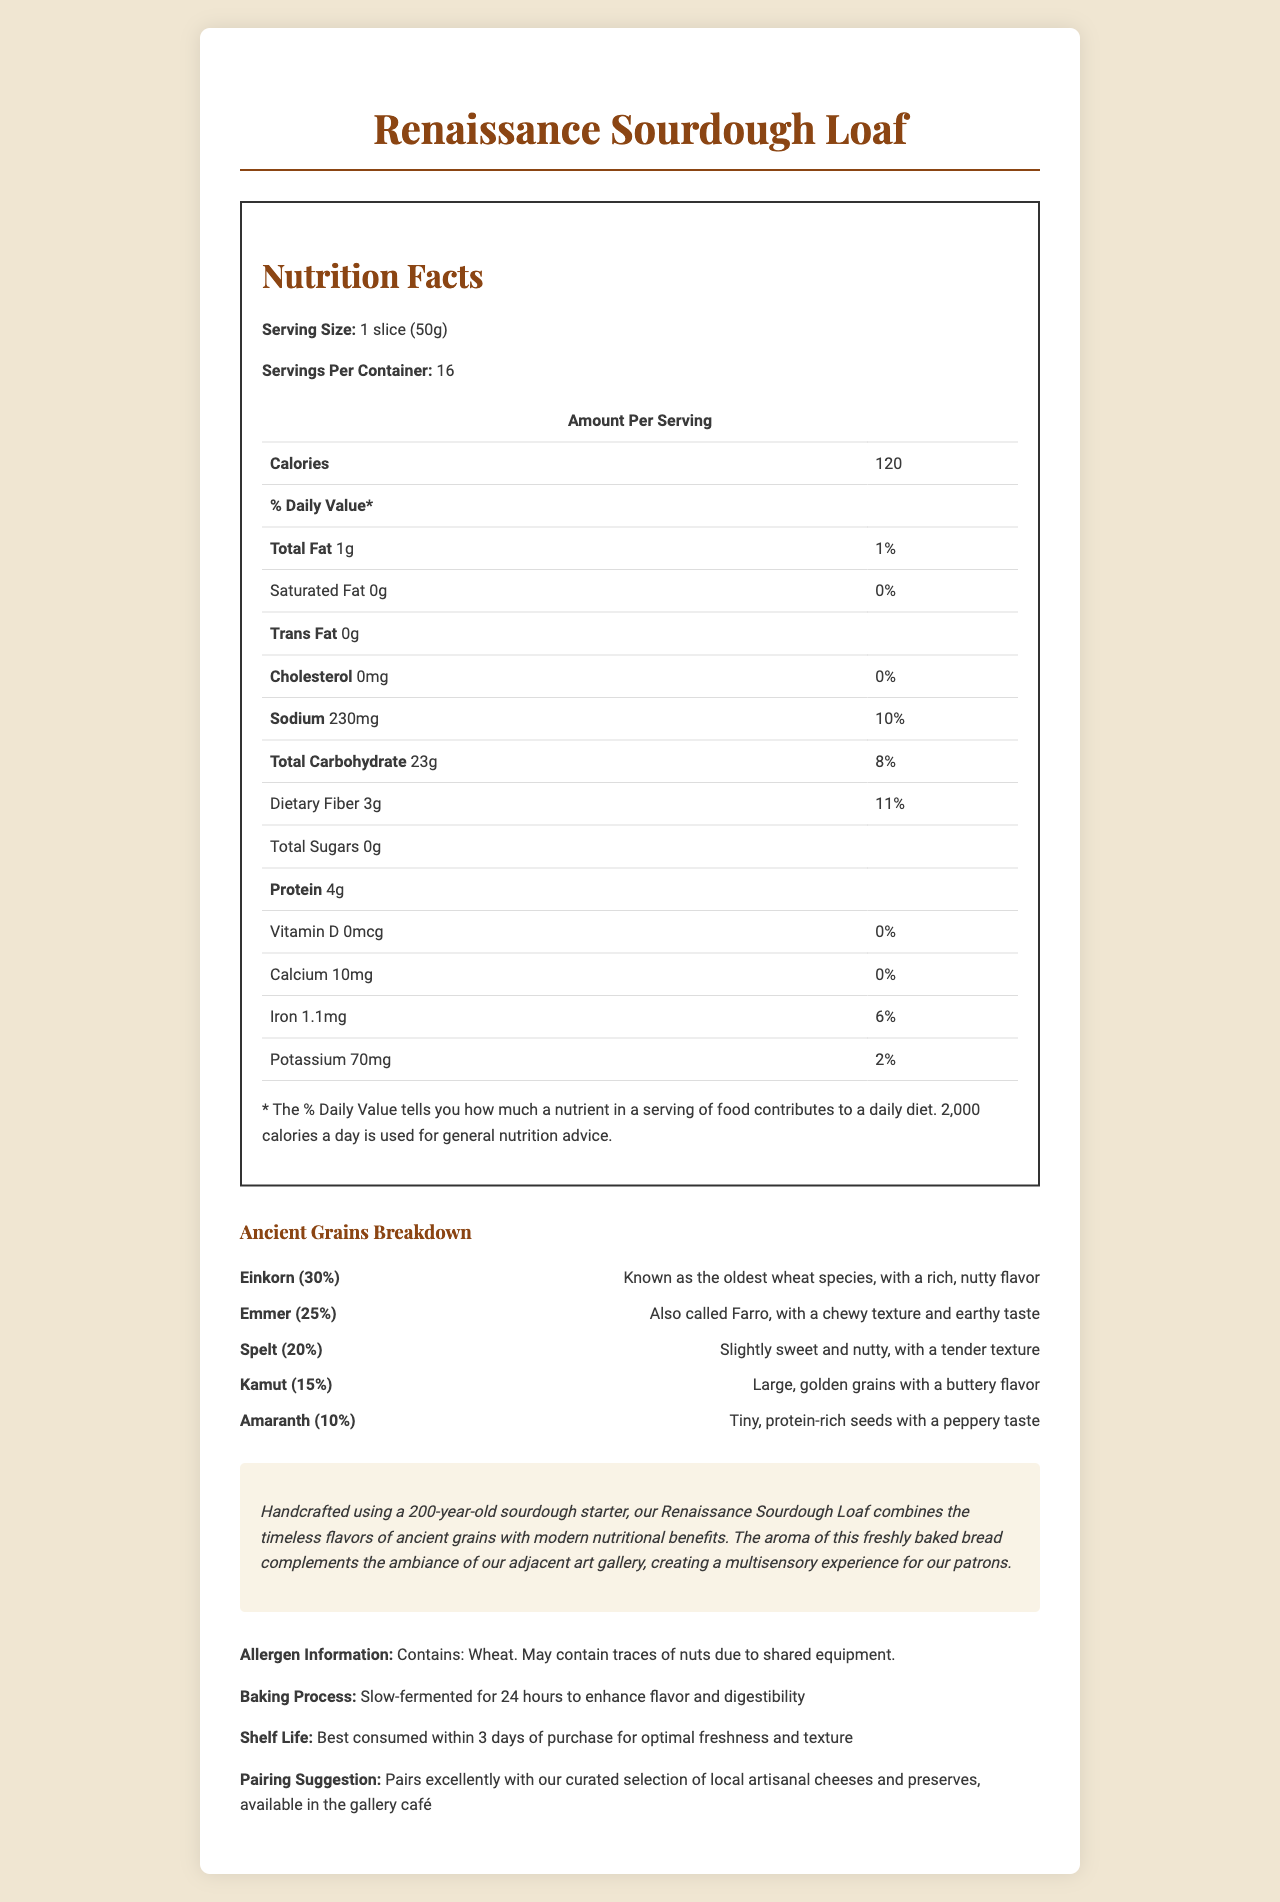what is the serving size? The serving size is explicitly mentioned at the top of the nutrition facts section in the document.
Answer: 1 slice (50g) how many calories are in one serving? The caloric content for one serving is listed as 120 under the nutrition facts section.
Answer: 120 what is the total carbohydrate amount per serving? The total carbohydrate amount is listed as 23g in the nutrition facts table.
Answer: 23g which ancient grain is used the most in the bread? Einkorn makes up 30% of the ancient grains used, which is the highest percentage among all the listed grains.
Answer: Einkorn how much sodium is in one slice of bread? The sodium amount per serving is specified as 230mg in the nutrition facts section.
Answer: 230mg which grain is described as having a nutty flavor and is the oldest wheat species? A. Kamu B. Amaranth C. Einkorn D. Spelt Einkorn is described as having a rich, nutty flavor and is known as the oldest wheat species in the ancient grains breakdown.
Answer: C. Einkorn how long is the bread's fermentation process? A. 12 hours B. 18 hours C. 24 hours D. 36 hours The document states that the bread is slow-fermented for 24 hours to enhance flavor and digestibility.
Answer: C. 24 hours does the bread contain any traces of nuts? The allergen information mentions that the bread may contain traces of nuts due to shared equipment.
Answer: Yes does the bread contain any cholesterol? The document specifies that there is 0mg of cholesterol in the bread.
Answer: No please summarize the document. The document provides comprehensive details about the Renaissance Sourdough Loaf, including its nutritional content, types of ancient grains used, artisanal notes on its creation, allergen warnings, and pairing suggestions.
Answer: The Renaissance Sourdough Loaf is an artisanal bread with a nutritional breakdown, including details on ancient grains used. It contains 120 calories per serving, with various nutrient amounts listed. The bread incorporates ancient grains like Einkorn, Emmer, Spelt, Kamut, and Amaranth, each with a unique flavor profile. Additional notes describe the handmade process, allergen information, baking process, and pairing suggestions. what is the total amount of dietary fiber in the whole loaf? The dietary fiber per serving is 3g, and there are 16 servings per container (3g * 16 = 48g).
Answer: 48g what percentage of the daily value of iron does one serving provide? The document specifies that one serving contains 6% of the daily value of iron.
Answer: 6% what is the source of the 200-year-old sourdough starter? The document mentions the use of a 200-year-old sourdough starter but does not provide details about its source.
Answer: Not enough information 